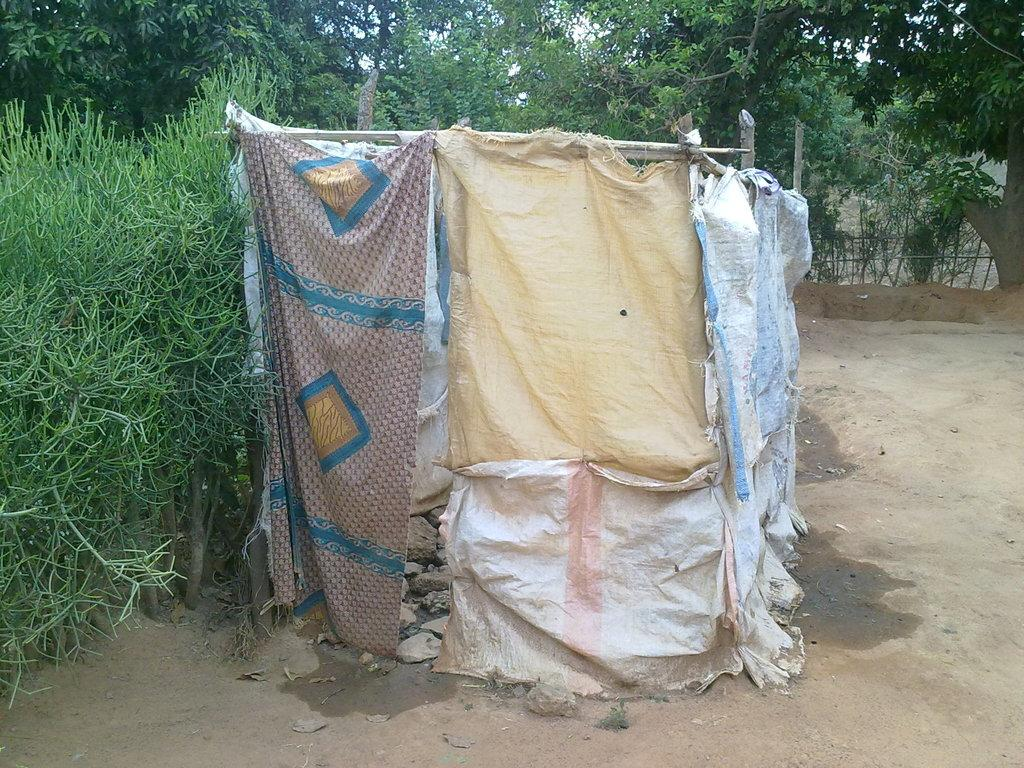What type of structure is present in the image? There is a small hut made up of covers in the image. What can be seen on the left side of the image? There are plants on the left side of the image. What is visible in the background of the image? There are trees visible in the background of the image. Can you hear the robin singing in the image? There is no robin present in the image, so it is not possible to hear it singing. 